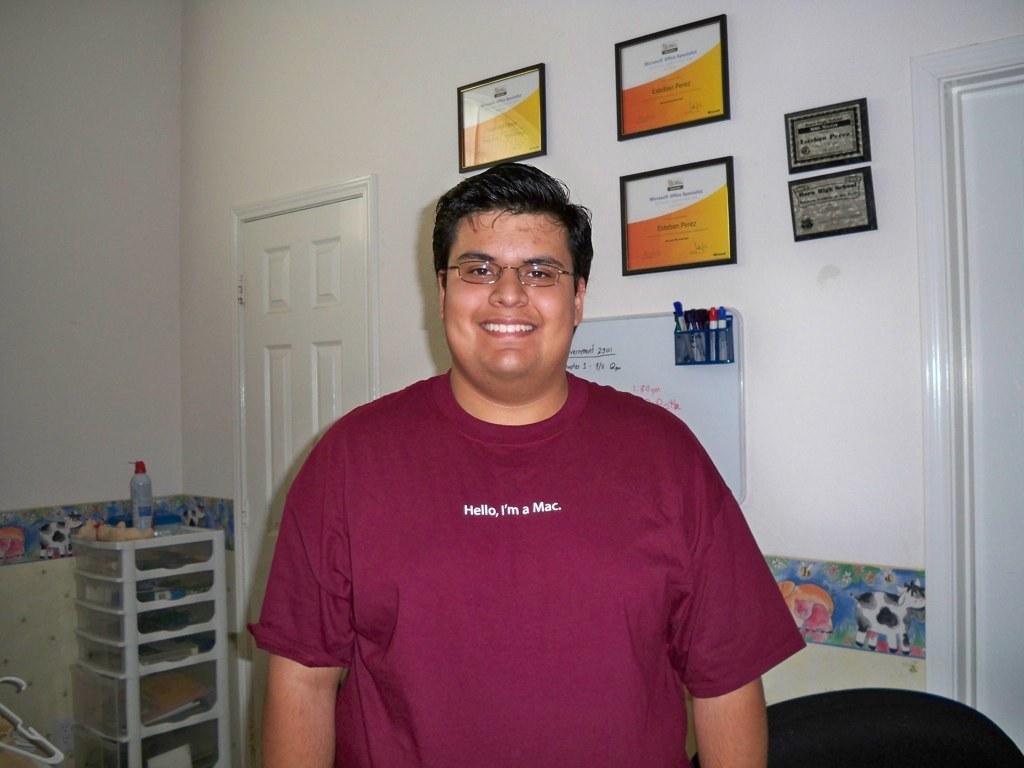Please provide a concise description of this image. In this picture we can see a man wore a spectacle and smiling and at the back of him we can see doors, frames on the wall, sketch pens, board, bottle and some objects. 